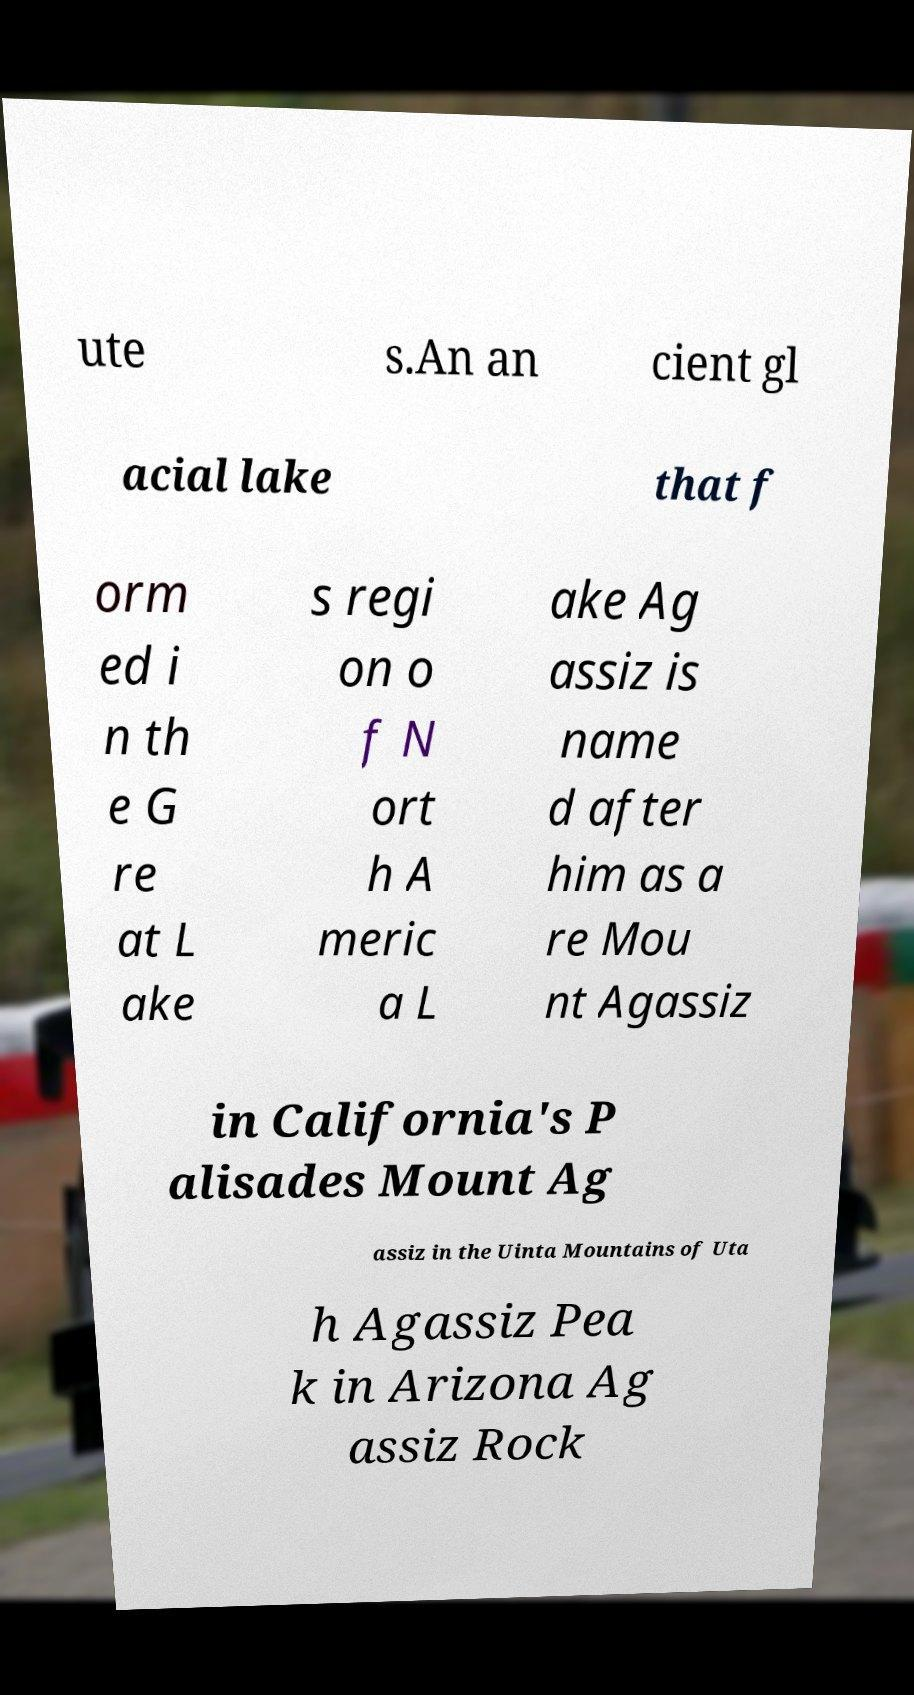There's text embedded in this image that I need extracted. Can you transcribe it verbatim? ute s.An an cient gl acial lake that f orm ed i n th e G re at L ake s regi on o f N ort h A meric a L ake Ag assiz is name d after him as a re Mou nt Agassiz in California's P alisades Mount Ag assiz in the Uinta Mountains of Uta h Agassiz Pea k in Arizona Ag assiz Rock 